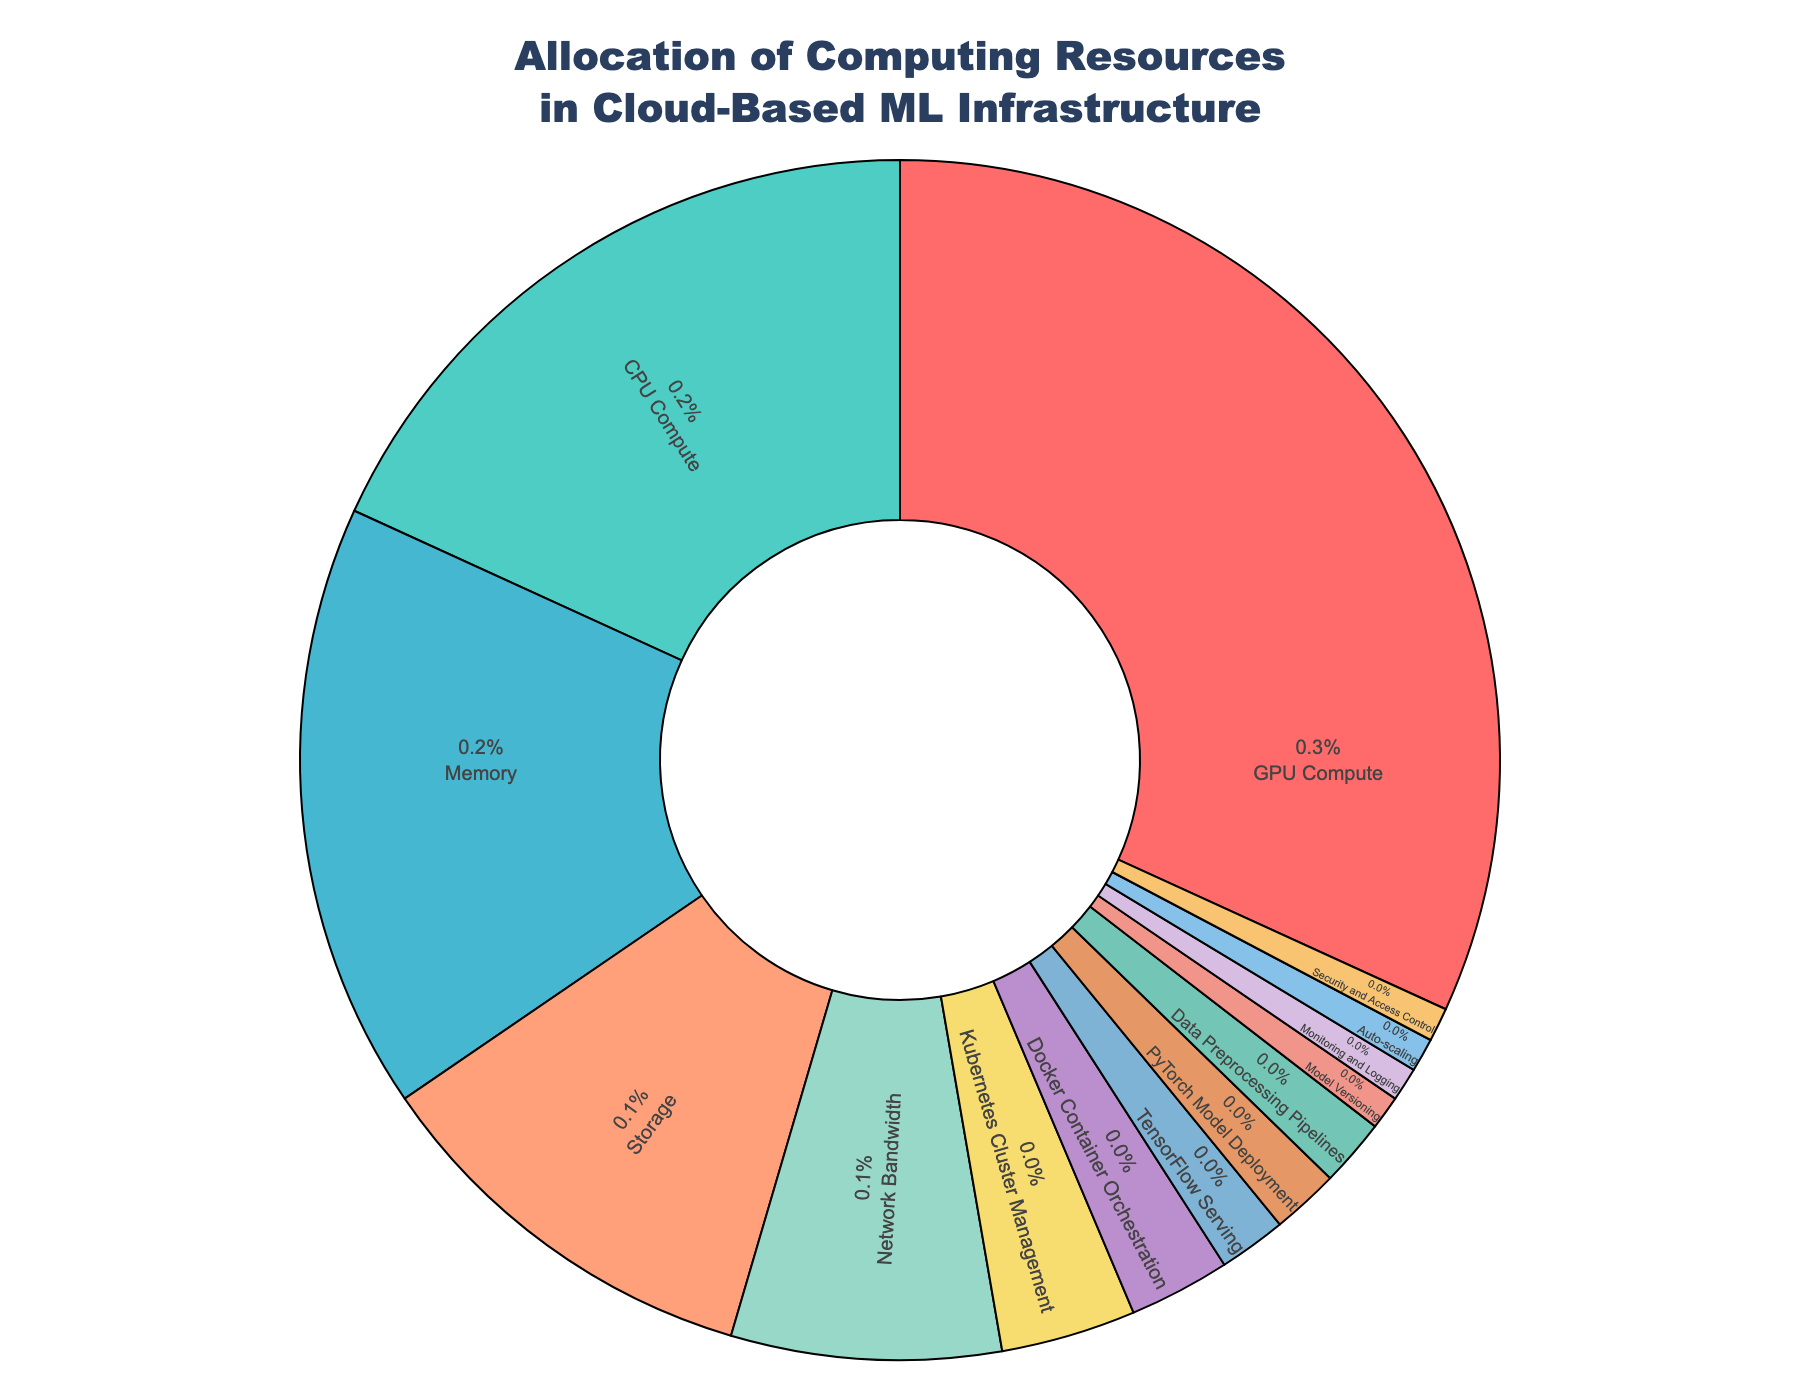Which resource has the highest allocation of computing resources? The figure shows the allocation percentages for each resource. The largest section of the pie chart is labeled "GPU Compute", which is 35%.
Answer: GPU Compute Which resource has the second-highest allocation? The next largest section of the pie chart is the one labeled "CPU Compute", which occupies 20% of the allocation.
Answer: CPU Compute What is the combined percentage of resources allocated to Memory and Storage? Memory is allocated 18% and Storage is allocated 12%. Adding these together gives 18% + 12% = 30%.
Answer: 30% Is the allocation for Network Bandwidth greater than or equal to the sum of Kubernetes Cluster Management and Docker Container Orchestration? Network Bandwidth is 8%. Kubernetes Cluster Management is 4% and Docker Container Orchestration is 3%. Their sum is 4% + 3% = 7%, which is less than 8%.
Answer: Yes What percentage of resources is allocated to TensorFlow Serving, PyTorch Model Deployment, and Data Preprocessing Pipelines combined? TensorFlow Serving is 2%, PyTorch Model Deployment is 2%, and Data Preprocessing Pipelines is 2%. Summing these up gives 2% + 2% + 2% = 6%.
Answer: 6% Which has a higher allocation: Kubernetes Cluster Management or Security and Access Control? Kubernetes Cluster Management is allocated 4%, whereas Security and Access Control is allocated 1%. Therefore, Kubernetes Cluster Management has a higher allocation.
Answer: Kubernetes Cluster Management What is the total percentage allocated to tasks related to machine learning models (TensorFlow Serving, PyTorch Model Deployment, and Model Versioning)? TensorFlow Serving has 2%, PyTorch Model Deployment has 2%, and Model Versioning has 1%. The total is 2% + 2% + 1% = 5%.
Answer: 5% Which resource designated with a color on the pie chart has the smallest allocation? The smallest section of the pie chart is Model Versioning, Monitoring and Logging, Auto-scaling, Security and Access Control—all have 1%.
Answer: Model Versioning, Monitoring and Logging, Auto-scaling, Security and Access Control What is the allocation for all resources other than GPU Compute and CPU Compute? Summing all the other percentages: Memory 18%, Storage 12%, Network Bandwidth 8%, Kubernetes Cluster Management 4%, Docker Container Orchestration 3%, TensorFlow Serving 2%, PyTorch Model Deployment 2%, Data Preprocessing Pipelines 2%, Model Versioning 1%, Monitoring and Logging 1%, Auto-scaling 1%, Security and Access Control 1%. This leads to 18% + 12% + 8% + 4% + 3% + 2% + 2% + 2% + 1% + 1% + 1% + 1% = 56%.
Answer: 56% What is the ratio of GPU Compute to CPU Compute allocation? GPU Compute is 35%, and CPU Compute is 20%. The ratio of GPU Compute to CPU Compute is 35:20 or simplified to 7:4.
Answer: 7:4 